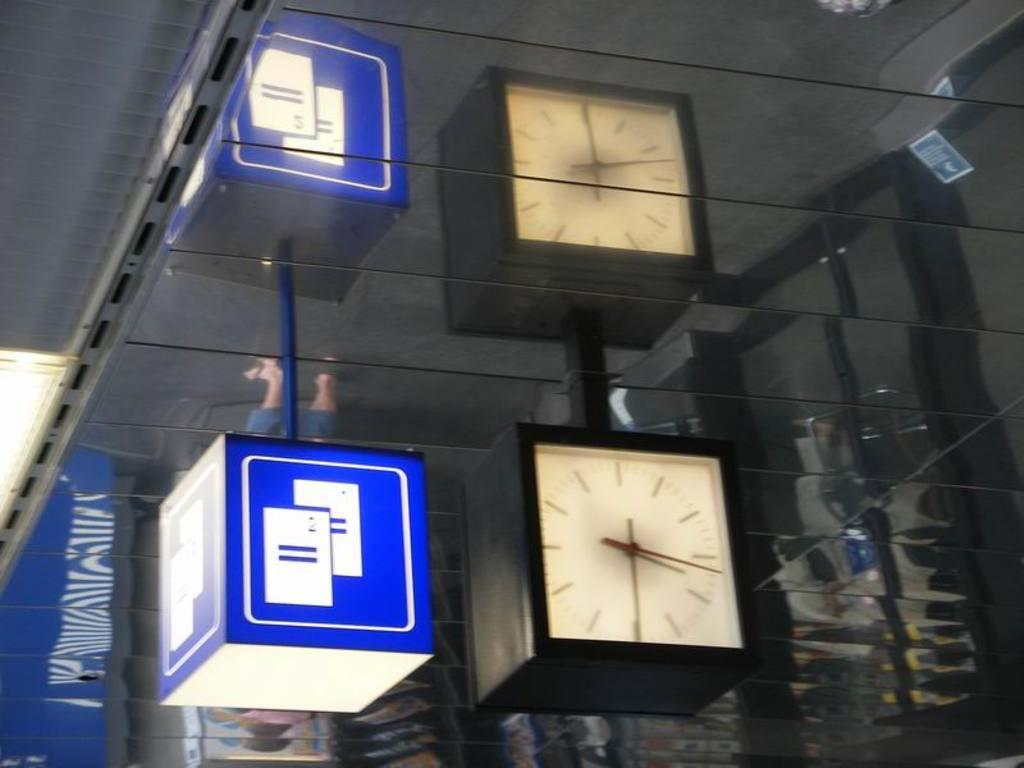What object in the image is used for telling time? There is a clock in the image, which is used for telling time. What other object can be seen in the center of the image? There is a sign box in the image. Can you describe the positioning of the clock and the sign box in the image? Both the clock and the sign box are in the center of the image. How many family members can be seen sneezing in the image? There are no family members or sneezing depicted in the image. What direction is the clock pointing in the image? The image does not show the clock pointing in any specific direction. 